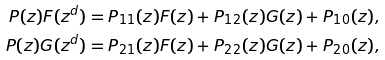Convert formula to latex. <formula><loc_0><loc_0><loc_500><loc_500>P ( z ) F ( z ^ { d } ) & = P _ { 1 1 } ( z ) F ( z ) + P _ { 1 2 } ( z ) G ( z ) + P _ { 1 0 } ( z ) , \\ P ( z ) G ( z ^ { d } ) & = P _ { 2 1 } ( z ) F ( z ) + P _ { 2 2 } ( z ) G ( z ) + P _ { 2 0 } ( z ) ,</formula> 